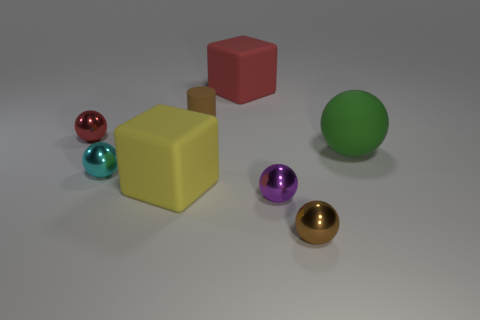Is the small cyan thing the same shape as the tiny matte thing?
Your response must be concise. No. Is there another small shiny thing of the same shape as the purple object?
Your answer should be very brief. Yes. What shape is the matte object that is left of the small brown thing that is behind the yellow cube?
Your answer should be very brief. Cube. What is the color of the metal sphere that is behind the green matte ball?
Keep it short and to the point. Red. There is a brown cylinder that is the same material as the large green ball; what is its size?
Your answer should be compact. Small. What is the size of the green matte thing that is the same shape as the tiny cyan metallic object?
Provide a succinct answer. Large. Are there any green rubber objects?
Your response must be concise. Yes. How many objects are large objects that are to the right of the yellow matte object or small brown balls?
Ensure brevity in your answer.  3. What is the material of the cyan ball that is the same size as the matte cylinder?
Your answer should be compact. Metal. There is a cube left of the large cube that is behind the big yellow rubber object; what is its color?
Offer a very short reply. Yellow. 